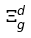Convert formula to latex. <formula><loc_0><loc_0><loc_500><loc_500>\Xi _ { g } ^ { d }</formula> 